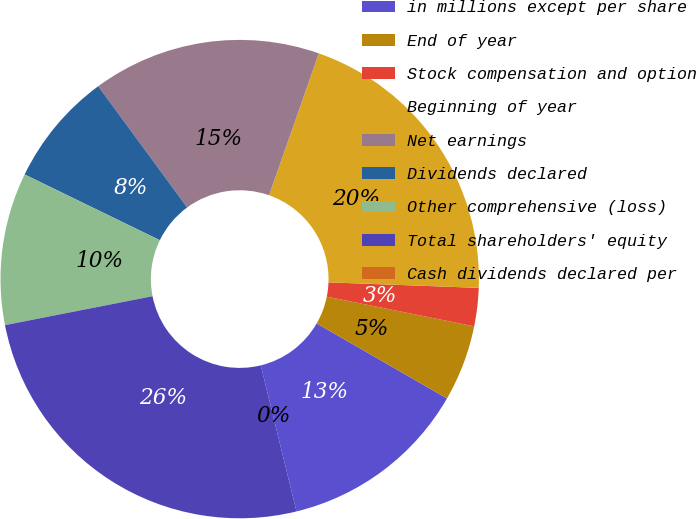<chart> <loc_0><loc_0><loc_500><loc_500><pie_chart><fcel>in millions except per share<fcel>End of year<fcel>Stock compensation and option<fcel>Beginning of year<fcel>Net earnings<fcel>Dividends declared<fcel>Other comprehensive (loss)<fcel>Total shareholders' equity<fcel>Cash dividends declared per<nl><fcel>12.87%<fcel>5.15%<fcel>2.58%<fcel>20.22%<fcel>15.44%<fcel>7.72%<fcel>10.29%<fcel>25.73%<fcel>0.0%<nl></chart> 